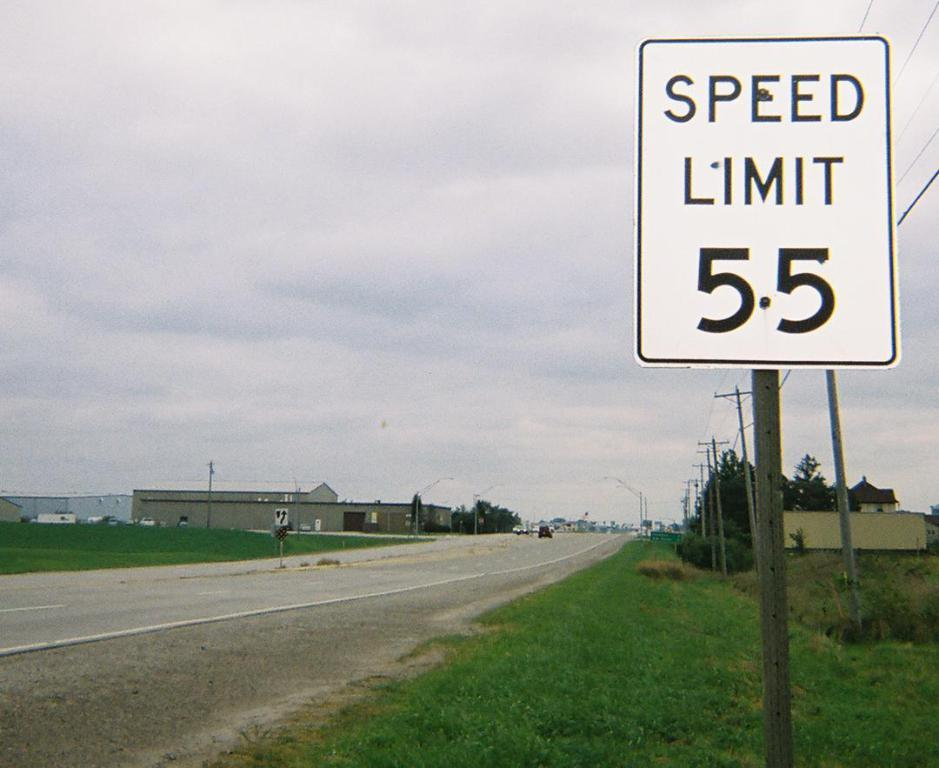<image>
Summarize the visual content of the image. A speed limit sign indicates the limit is 55. 